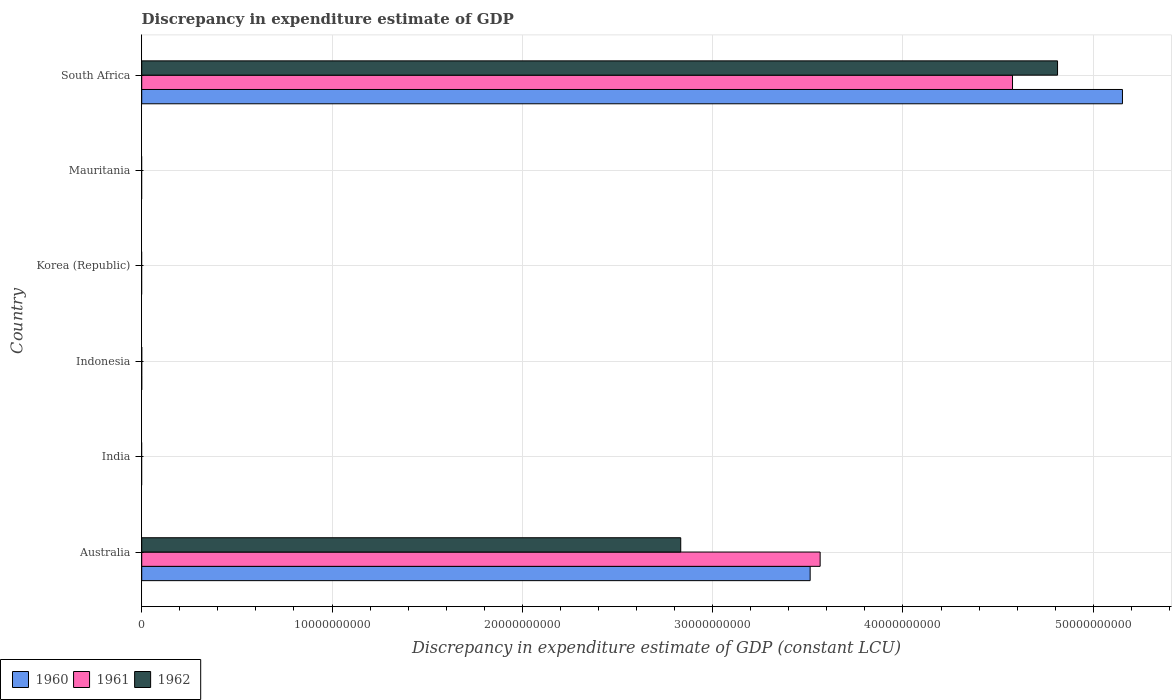Are the number of bars on each tick of the Y-axis equal?
Make the answer very short. No. How many bars are there on the 4th tick from the bottom?
Your answer should be compact. 0. Across all countries, what is the maximum discrepancy in expenditure estimate of GDP in 1962?
Offer a very short reply. 4.81e+1. In which country was the discrepancy in expenditure estimate of GDP in 1961 maximum?
Your answer should be very brief. South Africa. What is the total discrepancy in expenditure estimate of GDP in 1961 in the graph?
Offer a terse response. 8.14e+1. What is the difference between the discrepancy in expenditure estimate of GDP in 1960 in India and the discrepancy in expenditure estimate of GDP in 1961 in South Africa?
Keep it short and to the point. -4.58e+1. What is the average discrepancy in expenditure estimate of GDP in 1962 per country?
Your answer should be very brief. 1.27e+1. What is the difference between the discrepancy in expenditure estimate of GDP in 1961 and discrepancy in expenditure estimate of GDP in 1962 in Australia?
Ensure brevity in your answer.  7.33e+09. In how many countries, is the discrepancy in expenditure estimate of GDP in 1961 greater than 50000000000 LCU?
Provide a succinct answer. 0. Is the difference between the discrepancy in expenditure estimate of GDP in 1961 in Australia and South Africa greater than the difference between the discrepancy in expenditure estimate of GDP in 1962 in Australia and South Africa?
Give a very brief answer. Yes. What is the difference between the highest and the lowest discrepancy in expenditure estimate of GDP in 1960?
Keep it short and to the point. 5.15e+1. Is the sum of the discrepancy in expenditure estimate of GDP in 1961 in Australia and South Africa greater than the maximum discrepancy in expenditure estimate of GDP in 1960 across all countries?
Offer a terse response. Yes. How many bars are there?
Your response must be concise. 6. How many countries are there in the graph?
Provide a short and direct response. 6. Does the graph contain any zero values?
Make the answer very short. Yes. How many legend labels are there?
Your answer should be compact. 3. How are the legend labels stacked?
Your answer should be compact. Horizontal. What is the title of the graph?
Offer a terse response. Discrepancy in expenditure estimate of GDP. Does "2004" appear as one of the legend labels in the graph?
Offer a very short reply. No. What is the label or title of the X-axis?
Provide a short and direct response. Discrepancy in expenditure estimate of GDP (constant LCU). What is the Discrepancy in expenditure estimate of GDP (constant LCU) of 1960 in Australia?
Offer a very short reply. 3.51e+1. What is the Discrepancy in expenditure estimate of GDP (constant LCU) of 1961 in Australia?
Provide a succinct answer. 3.56e+1. What is the Discrepancy in expenditure estimate of GDP (constant LCU) in 1962 in Australia?
Offer a terse response. 2.83e+1. What is the Discrepancy in expenditure estimate of GDP (constant LCU) in 1961 in India?
Keep it short and to the point. 0. What is the Discrepancy in expenditure estimate of GDP (constant LCU) in 1962 in India?
Make the answer very short. 0. What is the Discrepancy in expenditure estimate of GDP (constant LCU) in 1961 in Indonesia?
Keep it short and to the point. 0. What is the Discrepancy in expenditure estimate of GDP (constant LCU) of 1962 in Indonesia?
Keep it short and to the point. 0. What is the Discrepancy in expenditure estimate of GDP (constant LCU) of 1960 in Korea (Republic)?
Provide a short and direct response. 0. What is the Discrepancy in expenditure estimate of GDP (constant LCU) in 1962 in Korea (Republic)?
Offer a terse response. 0. What is the Discrepancy in expenditure estimate of GDP (constant LCU) in 1961 in Mauritania?
Offer a very short reply. 0. What is the Discrepancy in expenditure estimate of GDP (constant LCU) in 1960 in South Africa?
Ensure brevity in your answer.  5.15e+1. What is the Discrepancy in expenditure estimate of GDP (constant LCU) of 1961 in South Africa?
Offer a very short reply. 4.58e+1. What is the Discrepancy in expenditure estimate of GDP (constant LCU) of 1962 in South Africa?
Provide a succinct answer. 4.81e+1. Across all countries, what is the maximum Discrepancy in expenditure estimate of GDP (constant LCU) of 1960?
Keep it short and to the point. 5.15e+1. Across all countries, what is the maximum Discrepancy in expenditure estimate of GDP (constant LCU) of 1961?
Provide a succinct answer. 4.58e+1. Across all countries, what is the maximum Discrepancy in expenditure estimate of GDP (constant LCU) of 1962?
Provide a short and direct response. 4.81e+1. Across all countries, what is the minimum Discrepancy in expenditure estimate of GDP (constant LCU) of 1961?
Your answer should be very brief. 0. Across all countries, what is the minimum Discrepancy in expenditure estimate of GDP (constant LCU) in 1962?
Your response must be concise. 0. What is the total Discrepancy in expenditure estimate of GDP (constant LCU) in 1960 in the graph?
Offer a very short reply. 8.67e+1. What is the total Discrepancy in expenditure estimate of GDP (constant LCU) of 1961 in the graph?
Give a very brief answer. 8.14e+1. What is the total Discrepancy in expenditure estimate of GDP (constant LCU) of 1962 in the graph?
Make the answer very short. 7.64e+1. What is the difference between the Discrepancy in expenditure estimate of GDP (constant LCU) of 1960 in Australia and that in South Africa?
Your response must be concise. -1.64e+1. What is the difference between the Discrepancy in expenditure estimate of GDP (constant LCU) of 1961 in Australia and that in South Africa?
Give a very brief answer. -1.01e+1. What is the difference between the Discrepancy in expenditure estimate of GDP (constant LCU) in 1962 in Australia and that in South Africa?
Ensure brevity in your answer.  -1.98e+1. What is the difference between the Discrepancy in expenditure estimate of GDP (constant LCU) in 1960 in Australia and the Discrepancy in expenditure estimate of GDP (constant LCU) in 1961 in South Africa?
Make the answer very short. -1.06e+1. What is the difference between the Discrepancy in expenditure estimate of GDP (constant LCU) of 1960 in Australia and the Discrepancy in expenditure estimate of GDP (constant LCU) of 1962 in South Africa?
Provide a succinct answer. -1.30e+1. What is the difference between the Discrepancy in expenditure estimate of GDP (constant LCU) of 1961 in Australia and the Discrepancy in expenditure estimate of GDP (constant LCU) of 1962 in South Africa?
Make the answer very short. -1.25e+1. What is the average Discrepancy in expenditure estimate of GDP (constant LCU) in 1960 per country?
Provide a succinct answer. 1.44e+1. What is the average Discrepancy in expenditure estimate of GDP (constant LCU) of 1961 per country?
Ensure brevity in your answer.  1.36e+1. What is the average Discrepancy in expenditure estimate of GDP (constant LCU) in 1962 per country?
Keep it short and to the point. 1.27e+1. What is the difference between the Discrepancy in expenditure estimate of GDP (constant LCU) of 1960 and Discrepancy in expenditure estimate of GDP (constant LCU) of 1961 in Australia?
Keep it short and to the point. -5.25e+08. What is the difference between the Discrepancy in expenditure estimate of GDP (constant LCU) of 1960 and Discrepancy in expenditure estimate of GDP (constant LCU) of 1962 in Australia?
Provide a succinct answer. 6.80e+09. What is the difference between the Discrepancy in expenditure estimate of GDP (constant LCU) in 1961 and Discrepancy in expenditure estimate of GDP (constant LCU) in 1962 in Australia?
Your answer should be compact. 7.33e+09. What is the difference between the Discrepancy in expenditure estimate of GDP (constant LCU) of 1960 and Discrepancy in expenditure estimate of GDP (constant LCU) of 1961 in South Africa?
Your response must be concise. 5.78e+09. What is the difference between the Discrepancy in expenditure estimate of GDP (constant LCU) in 1960 and Discrepancy in expenditure estimate of GDP (constant LCU) in 1962 in South Africa?
Provide a succinct answer. 3.41e+09. What is the difference between the Discrepancy in expenditure estimate of GDP (constant LCU) of 1961 and Discrepancy in expenditure estimate of GDP (constant LCU) of 1962 in South Africa?
Keep it short and to the point. -2.37e+09. What is the ratio of the Discrepancy in expenditure estimate of GDP (constant LCU) in 1960 in Australia to that in South Africa?
Keep it short and to the point. 0.68. What is the ratio of the Discrepancy in expenditure estimate of GDP (constant LCU) in 1961 in Australia to that in South Africa?
Your answer should be very brief. 0.78. What is the ratio of the Discrepancy in expenditure estimate of GDP (constant LCU) in 1962 in Australia to that in South Africa?
Keep it short and to the point. 0.59. What is the difference between the highest and the lowest Discrepancy in expenditure estimate of GDP (constant LCU) of 1960?
Your answer should be very brief. 5.15e+1. What is the difference between the highest and the lowest Discrepancy in expenditure estimate of GDP (constant LCU) in 1961?
Ensure brevity in your answer.  4.58e+1. What is the difference between the highest and the lowest Discrepancy in expenditure estimate of GDP (constant LCU) in 1962?
Your response must be concise. 4.81e+1. 